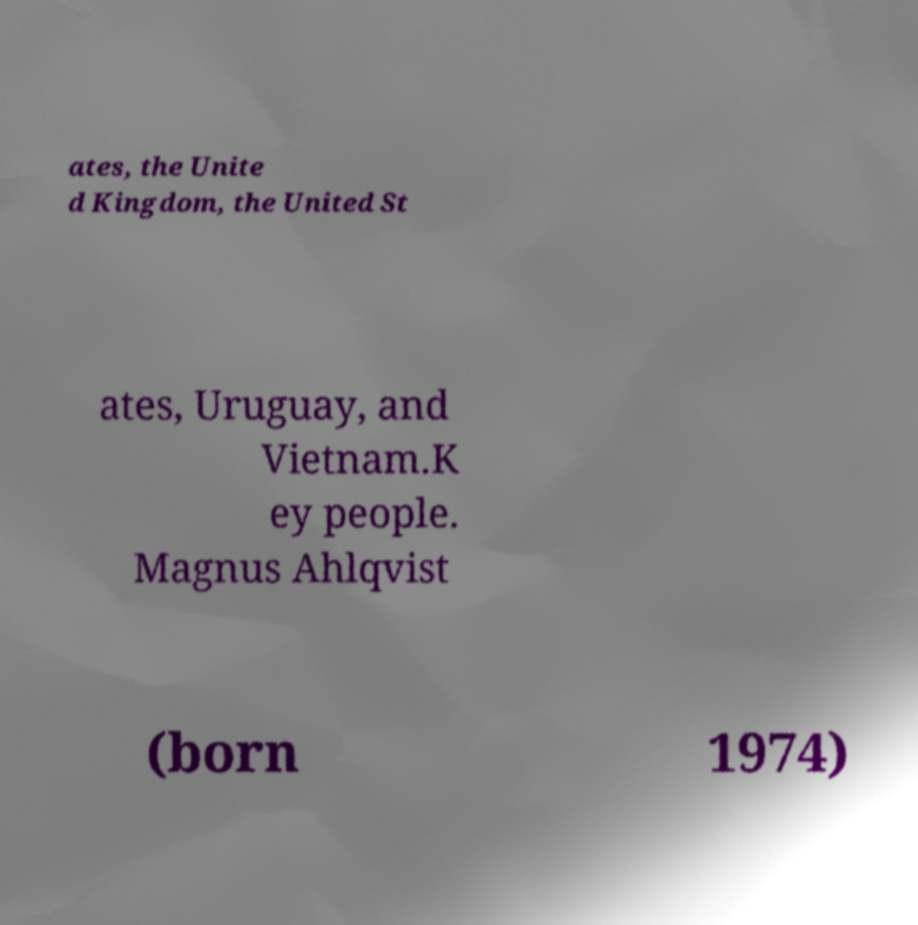There's text embedded in this image that I need extracted. Can you transcribe it verbatim? ates, the Unite d Kingdom, the United St ates, Uruguay, and Vietnam.K ey people. Magnus Ahlqvist (born 1974) 